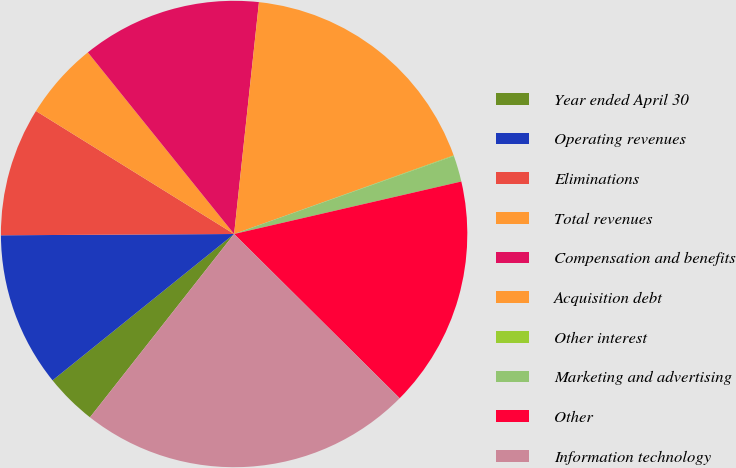Convert chart to OTSL. <chart><loc_0><loc_0><loc_500><loc_500><pie_chart><fcel>Year ended April 30<fcel>Operating revenues<fcel>Eliminations<fcel>Total revenues<fcel>Compensation and benefits<fcel>Acquisition debt<fcel>Other interest<fcel>Marketing and advertising<fcel>Other<fcel>Information technology<nl><fcel>3.6%<fcel>10.71%<fcel>8.93%<fcel>5.37%<fcel>12.49%<fcel>17.83%<fcel>0.04%<fcel>1.82%<fcel>16.05%<fcel>23.17%<nl></chart> 